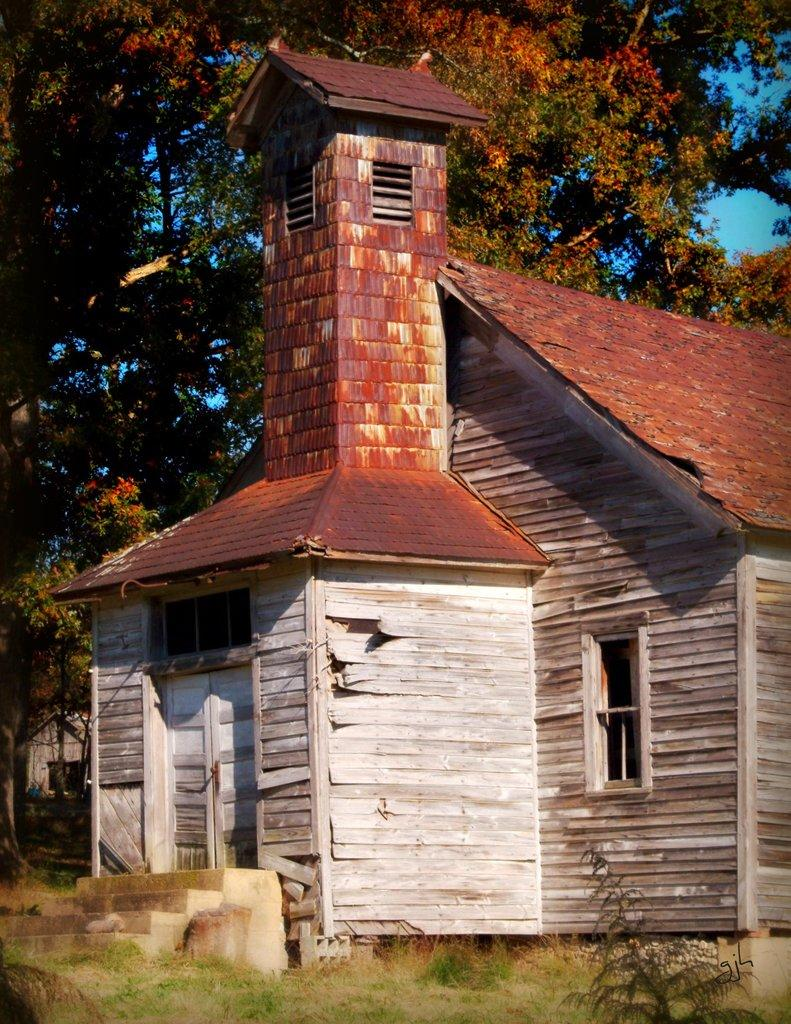What type of vegetation is present in the image? There is grass in the image. What type of structure is visible in the image? There is a house in the image. What architectural feature is present in the image? There are steps in the image. What other natural elements can be seen in the image? There are trees in the image. What is visible in the background of the image? The sky is visible in the background of the image. Can you describe the dog's tail in the image? There is no dog present in the image, so there is no tail to describe. What type of operation is being performed on the house in the image? There is no operation being performed on the house in the image; it appears to be a regular house. 